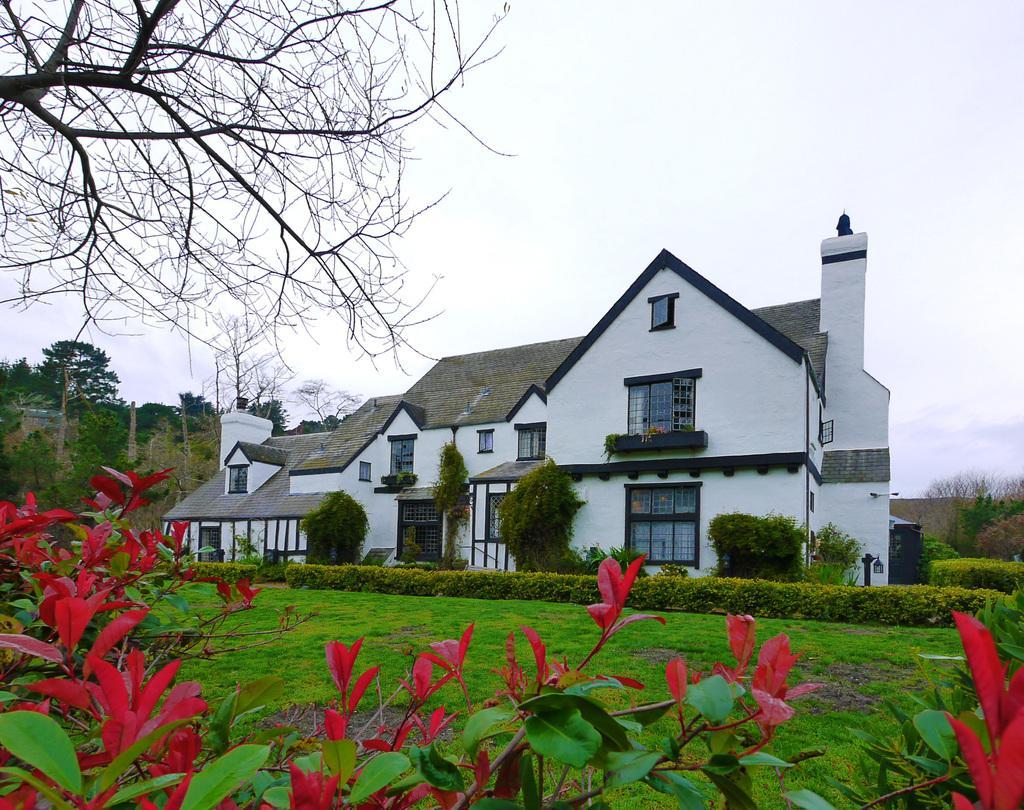In one or two sentences, can you explain what this image depicts? In this image I can see a building in white and gray color, at left I can see trees in green color and sky is in white color. 